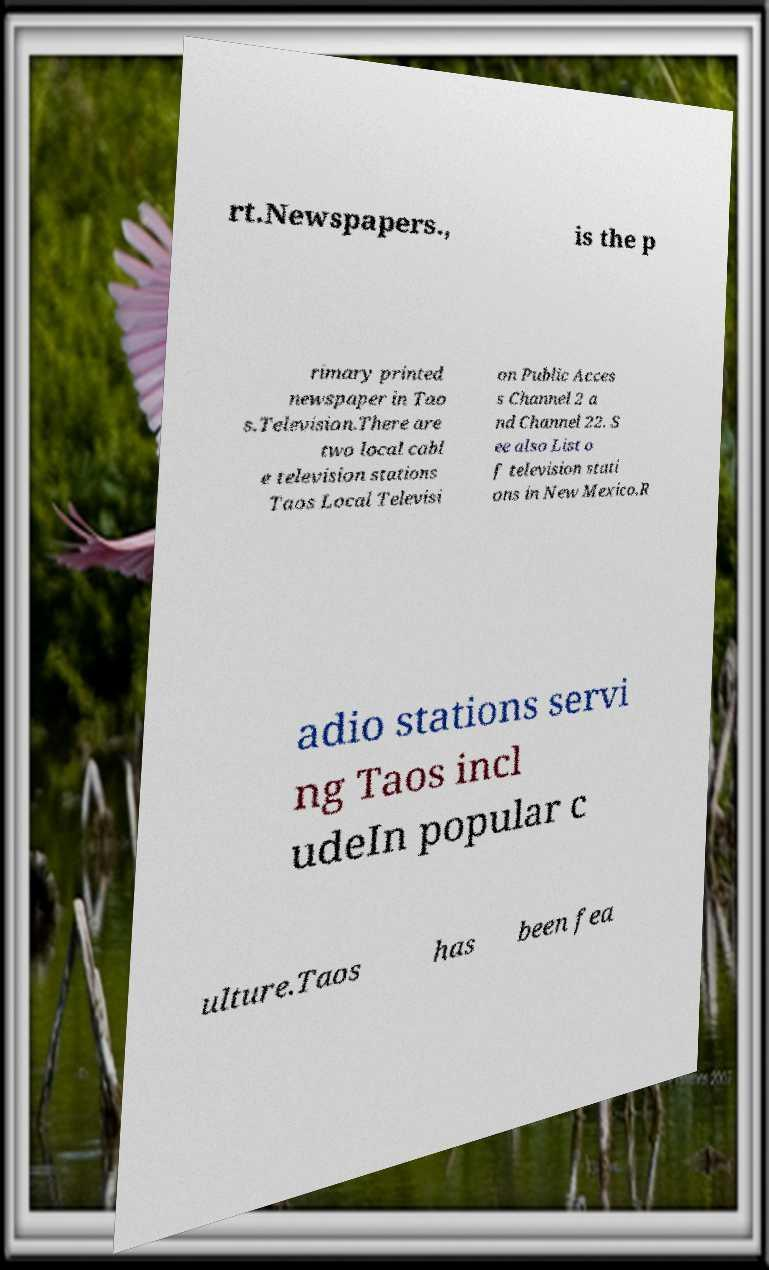Could you assist in decoding the text presented in this image and type it out clearly? rt.Newspapers., is the p rimary printed newspaper in Tao s.Television.There are two local cabl e television stations Taos Local Televisi on Public Acces s Channel 2 a nd Channel 22. S ee also List o f television stati ons in New Mexico.R adio stations servi ng Taos incl udeIn popular c ulture.Taos has been fea 